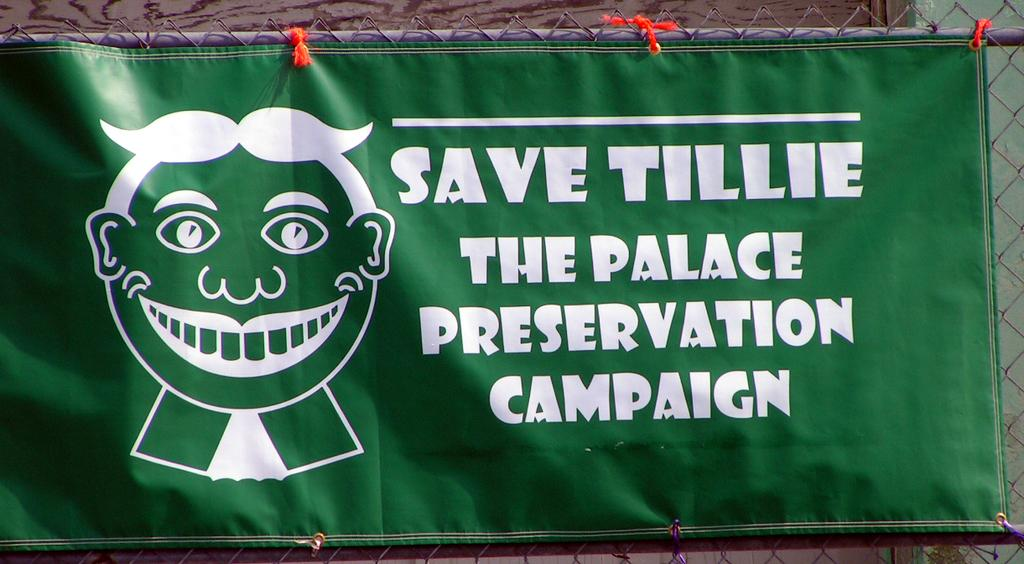Provide a one-sentence caption for the provided image. A green and white banner is hung on a fence in support of Saving Tillie. 